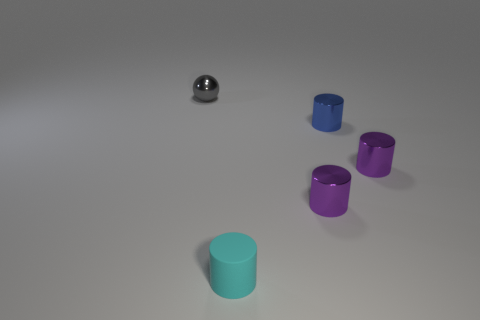What is the shape of the tiny blue thing that is made of the same material as the gray object?
Provide a succinct answer. Cylinder. Do the cyan thing and the gray metallic object have the same size?
Ensure brevity in your answer.  Yes. What is the size of the purple thing behind the purple object to the left of the blue thing?
Offer a terse response. Small. How many spheres are cyan things or blue metal objects?
Ensure brevity in your answer.  0. Do the gray metallic thing and the purple shiny thing that is to the right of the small blue thing have the same size?
Ensure brevity in your answer.  Yes. Are there more small matte objects that are to the left of the shiny sphere than large yellow matte cylinders?
Provide a succinct answer. No. What is the size of the blue object that is the same material as the gray object?
Offer a terse response. Small. Is there a small thing of the same color as the metal ball?
Offer a terse response. No. What number of objects are big cyan shiny spheres or tiny objects right of the gray ball?
Provide a succinct answer. 4. Is the number of blue metal cylinders greater than the number of big cyan rubber blocks?
Your answer should be compact. Yes. 